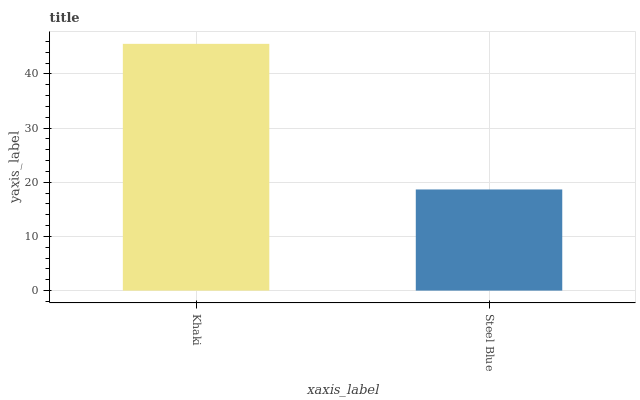Is Steel Blue the minimum?
Answer yes or no. Yes. Is Khaki the maximum?
Answer yes or no. Yes. Is Steel Blue the maximum?
Answer yes or no. No. Is Khaki greater than Steel Blue?
Answer yes or no. Yes. Is Steel Blue less than Khaki?
Answer yes or no. Yes. Is Steel Blue greater than Khaki?
Answer yes or no. No. Is Khaki less than Steel Blue?
Answer yes or no. No. Is Khaki the high median?
Answer yes or no. Yes. Is Steel Blue the low median?
Answer yes or no. Yes. Is Steel Blue the high median?
Answer yes or no. No. Is Khaki the low median?
Answer yes or no. No. 